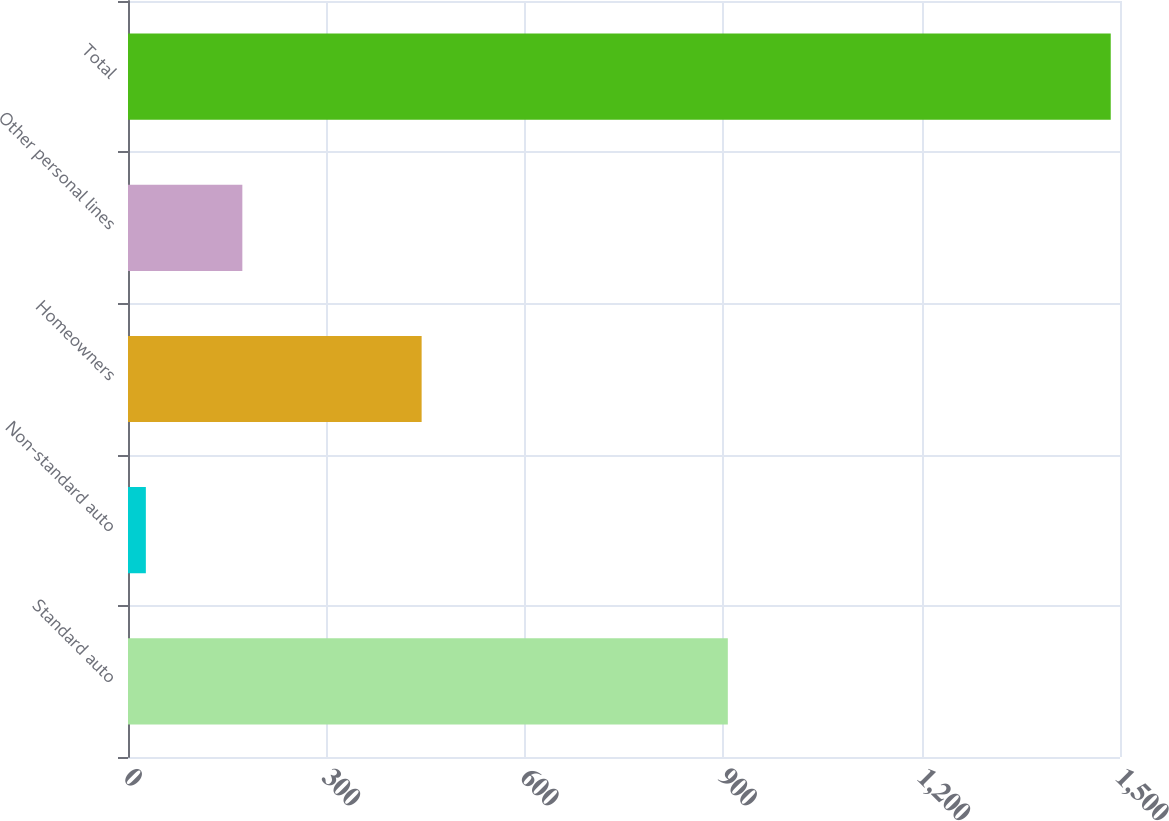<chart> <loc_0><loc_0><loc_500><loc_500><bar_chart><fcel>Standard auto<fcel>Non-standard auto<fcel>Homeowners<fcel>Other personal lines<fcel>Total<nl><fcel>907<fcel>27<fcel>444<fcel>172.9<fcel>1486<nl></chart> 